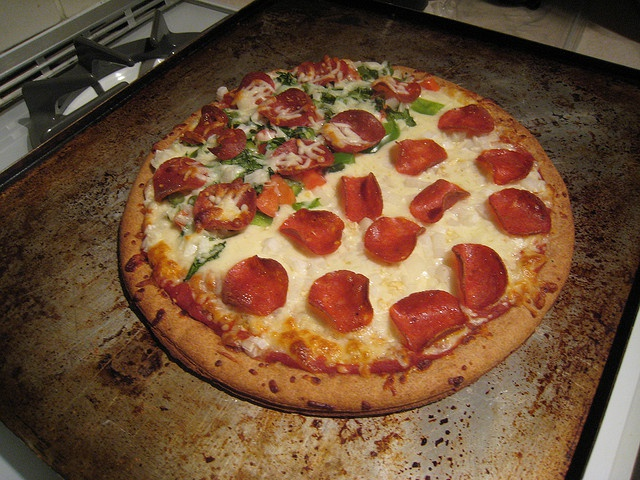Describe the objects in this image and their specific colors. I can see oven in black, maroon, brown, and olive tones and pizza in olive, brown, maroon, and tan tones in this image. 